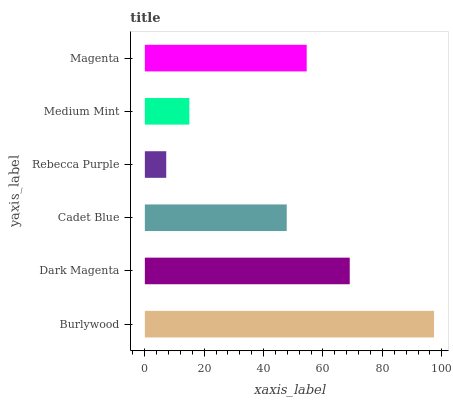Is Rebecca Purple the minimum?
Answer yes or no. Yes. Is Burlywood the maximum?
Answer yes or no. Yes. Is Dark Magenta the minimum?
Answer yes or no. No. Is Dark Magenta the maximum?
Answer yes or no. No. Is Burlywood greater than Dark Magenta?
Answer yes or no. Yes. Is Dark Magenta less than Burlywood?
Answer yes or no. Yes. Is Dark Magenta greater than Burlywood?
Answer yes or no. No. Is Burlywood less than Dark Magenta?
Answer yes or no. No. Is Magenta the high median?
Answer yes or no. Yes. Is Cadet Blue the low median?
Answer yes or no. Yes. Is Medium Mint the high median?
Answer yes or no. No. Is Dark Magenta the low median?
Answer yes or no. No. 